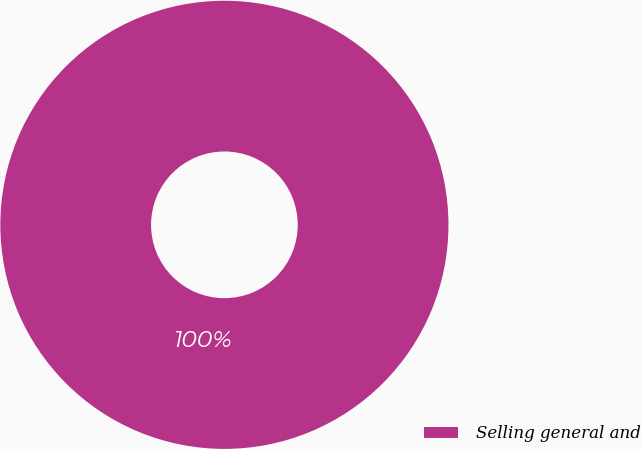Convert chart. <chart><loc_0><loc_0><loc_500><loc_500><pie_chart><fcel>Selling general and<nl><fcel>100.0%<nl></chart> 